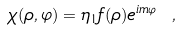Convert formula to latex. <formula><loc_0><loc_0><loc_500><loc_500>\chi ( \rho , \varphi ) = \eta _ { 1 } f ( \rho ) e ^ { i m \varphi } \ ,</formula> 